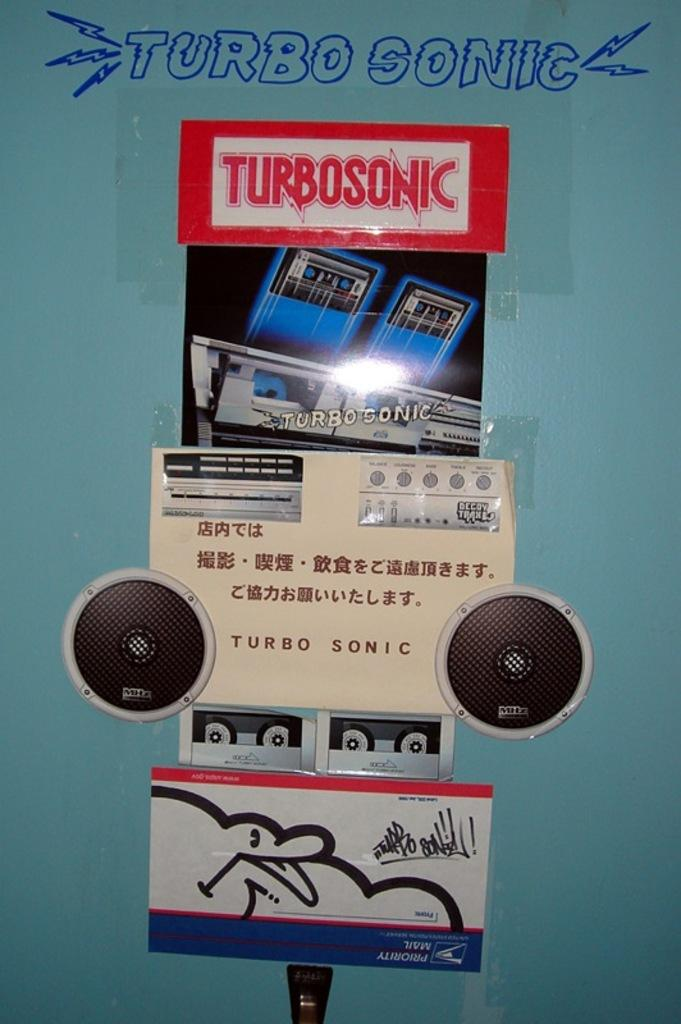<image>
Relay a brief, clear account of the picture shown. A various group of stickers depicting a Turbo Sonic music player. 